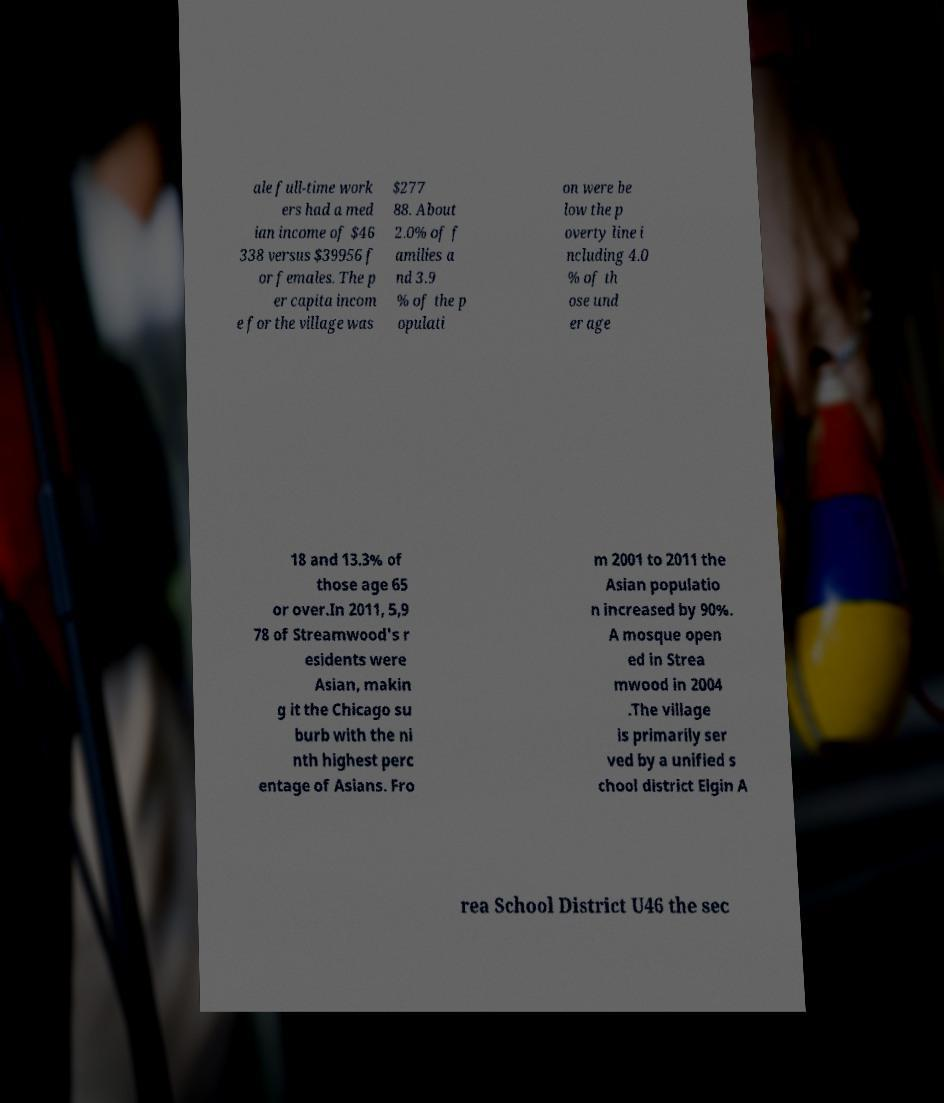Could you extract and type out the text from this image? ale full-time work ers had a med ian income of $46 338 versus $39956 f or females. The p er capita incom e for the village was $277 88. About 2.0% of f amilies a nd 3.9 % of the p opulati on were be low the p overty line i ncluding 4.0 % of th ose und er age 18 and 13.3% of those age 65 or over.In 2011, 5,9 78 of Streamwood's r esidents were Asian, makin g it the Chicago su burb with the ni nth highest perc entage of Asians. Fro m 2001 to 2011 the Asian populatio n increased by 90%. A mosque open ed in Strea mwood in 2004 .The village is primarily ser ved by a unified s chool district Elgin A rea School District U46 the sec 